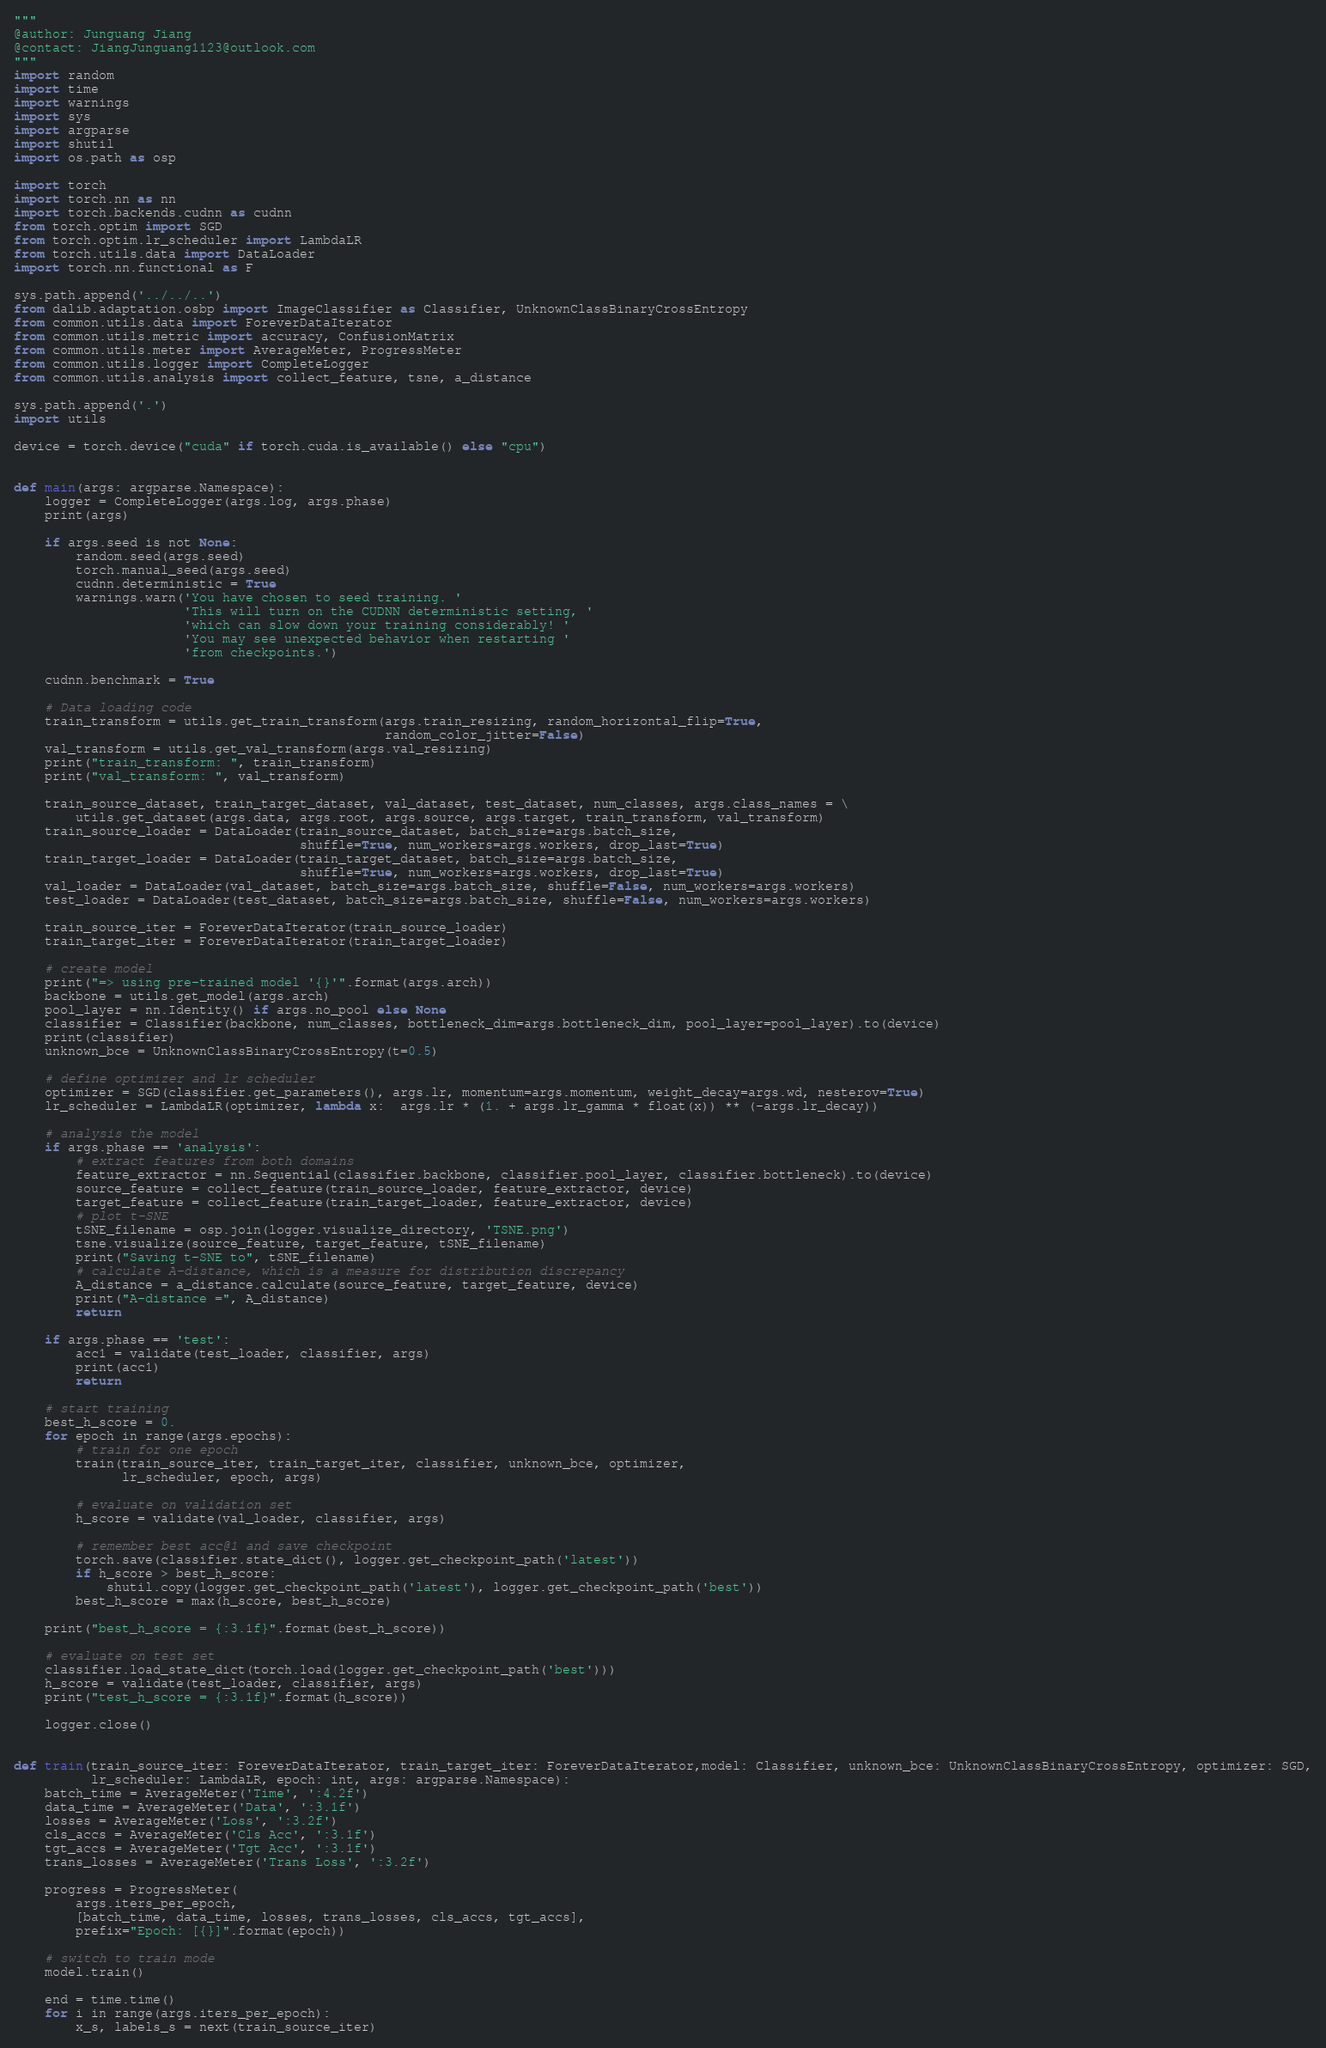<code> <loc_0><loc_0><loc_500><loc_500><_Python_>"""
@author: Junguang Jiang
@contact: JiangJunguang1123@outlook.com
"""
import random
import time
import warnings
import sys
import argparse
import shutil
import os.path as osp

import torch
import torch.nn as nn
import torch.backends.cudnn as cudnn
from torch.optim import SGD
from torch.optim.lr_scheduler import LambdaLR
from torch.utils.data import DataLoader
import torch.nn.functional as F

sys.path.append('../../..')
from dalib.adaptation.osbp import ImageClassifier as Classifier, UnknownClassBinaryCrossEntropy
from common.utils.data import ForeverDataIterator
from common.utils.metric import accuracy, ConfusionMatrix
from common.utils.meter import AverageMeter, ProgressMeter
from common.utils.logger import CompleteLogger
from common.utils.analysis import collect_feature, tsne, a_distance

sys.path.append('.')
import utils

device = torch.device("cuda" if torch.cuda.is_available() else "cpu")


def main(args: argparse.Namespace):
    logger = CompleteLogger(args.log, args.phase)
    print(args)

    if args.seed is not None:
        random.seed(args.seed)
        torch.manual_seed(args.seed)
        cudnn.deterministic = True
        warnings.warn('You have chosen to seed training. '
                      'This will turn on the CUDNN deterministic setting, '
                      'which can slow down your training considerably! '
                      'You may see unexpected behavior when restarting '
                      'from checkpoints.')

    cudnn.benchmark = True

    # Data loading code
    train_transform = utils.get_train_transform(args.train_resizing, random_horizontal_flip=True,
                                                random_color_jitter=False)
    val_transform = utils.get_val_transform(args.val_resizing)
    print("train_transform: ", train_transform)
    print("val_transform: ", val_transform)

    train_source_dataset, train_target_dataset, val_dataset, test_dataset, num_classes, args.class_names = \
        utils.get_dataset(args.data, args.root, args.source, args.target, train_transform, val_transform)
    train_source_loader = DataLoader(train_source_dataset, batch_size=args.batch_size,
                                     shuffle=True, num_workers=args.workers, drop_last=True)
    train_target_loader = DataLoader(train_target_dataset, batch_size=args.batch_size,
                                     shuffle=True, num_workers=args.workers, drop_last=True)
    val_loader = DataLoader(val_dataset, batch_size=args.batch_size, shuffle=False, num_workers=args.workers)
    test_loader = DataLoader(test_dataset, batch_size=args.batch_size, shuffle=False, num_workers=args.workers)

    train_source_iter = ForeverDataIterator(train_source_loader)
    train_target_iter = ForeverDataIterator(train_target_loader)

    # create model
    print("=> using pre-trained model '{}'".format(args.arch))
    backbone = utils.get_model(args.arch)
    pool_layer = nn.Identity() if args.no_pool else None
    classifier = Classifier(backbone, num_classes, bottleneck_dim=args.bottleneck_dim, pool_layer=pool_layer).to(device)
    print(classifier)
    unknown_bce = UnknownClassBinaryCrossEntropy(t=0.5)

    # define optimizer and lr scheduler
    optimizer = SGD(classifier.get_parameters(), args.lr, momentum=args.momentum, weight_decay=args.wd, nesterov=True)
    lr_scheduler = LambdaLR(optimizer, lambda x:  args.lr * (1. + args.lr_gamma * float(x)) ** (-args.lr_decay))

    # analysis the model
    if args.phase == 'analysis':
        # extract features from both domains
        feature_extractor = nn.Sequential(classifier.backbone, classifier.pool_layer, classifier.bottleneck).to(device)
        source_feature = collect_feature(train_source_loader, feature_extractor, device)
        target_feature = collect_feature(train_target_loader, feature_extractor, device)
        # plot t-SNE
        tSNE_filename = osp.join(logger.visualize_directory, 'TSNE.png')
        tsne.visualize(source_feature, target_feature, tSNE_filename)
        print("Saving t-SNE to", tSNE_filename)
        # calculate A-distance, which is a measure for distribution discrepancy
        A_distance = a_distance.calculate(source_feature, target_feature, device)
        print("A-distance =", A_distance)
        return

    if args.phase == 'test':
        acc1 = validate(test_loader, classifier, args)
        print(acc1)
        return

    # start training
    best_h_score = 0.
    for epoch in range(args.epochs):
        # train for one epoch
        train(train_source_iter, train_target_iter, classifier, unknown_bce, optimizer,
              lr_scheduler, epoch, args)

        # evaluate on validation set
        h_score = validate(val_loader, classifier, args)

        # remember best acc@1 and save checkpoint
        torch.save(classifier.state_dict(), logger.get_checkpoint_path('latest'))
        if h_score > best_h_score:
            shutil.copy(logger.get_checkpoint_path('latest'), logger.get_checkpoint_path('best'))
        best_h_score = max(h_score, best_h_score)

    print("best_h_score = {:3.1f}".format(best_h_score))

    # evaluate on test set
    classifier.load_state_dict(torch.load(logger.get_checkpoint_path('best')))
    h_score = validate(test_loader, classifier, args)
    print("test_h_score = {:3.1f}".format(h_score))

    logger.close()


def train(train_source_iter: ForeverDataIterator, train_target_iter: ForeverDataIterator,model: Classifier, unknown_bce: UnknownClassBinaryCrossEntropy, optimizer: SGD,
          lr_scheduler: LambdaLR, epoch: int, args: argparse.Namespace):
    batch_time = AverageMeter('Time', ':4.2f')
    data_time = AverageMeter('Data', ':3.1f')
    losses = AverageMeter('Loss', ':3.2f')
    cls_accs = AverageMeter('Cls Acc', ':3.1f')
    tgt_accs = AverageMeter('Tgt Acc', ':3.1f')
    trans_losses = AverageMeter('Trans Loss', ':3.2f')

    progress = ProgressMeter(
        args.iters_per_epoch,
        [batch_time, data_time, losses, trans_losses, cls_accs, tgt_accs],
        prefix="Epoch: [{}]".format(epoch))

    # switch to train mode
    model.train()

    end = time.time()
    for i in range(args.iters_per_epoch):
        x_s, labels_s = next(train_source_iter)</code> 